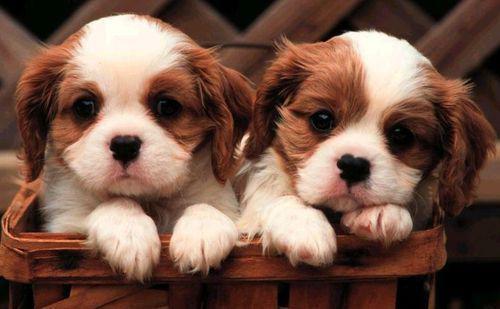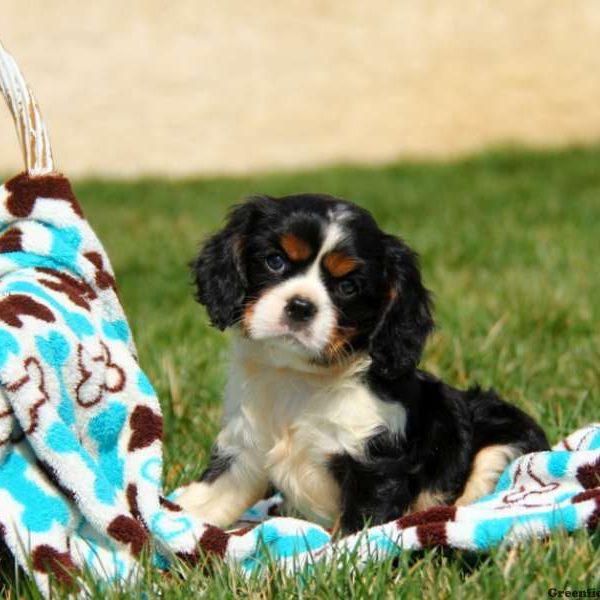The first image is the image on the left, the second image is the image on the right. For the images shown, is this caption "An image shows exactly two look-alike puppies." true? Answer yes or no. Yes. 